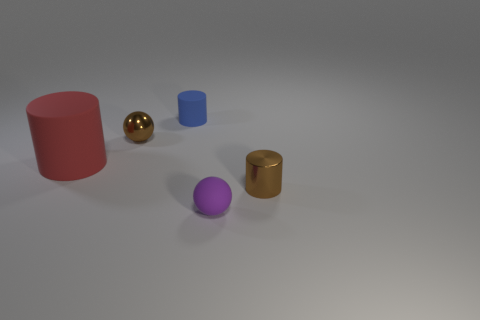Add 4 small matte objects. How many objects exist? 9 Subtract all big red cylinders. How many cylinders are left? 2 Subtract all balls. How many objects are left? 3 Add 5 tiny brown metal cylinders. How many tiny brown metal cylinders are left? 6 Add 1 gray matte objects. How many gray matte objects exist? 1 Subtract 0 green cylinders. How many objects are left? 5 Subtract all purple balls. Subtract all blue cylinders. How many balls are left? 1 Subtract all tiny brown metallic cylinders. Subtract all tiny purple matte things. How many objects are left? 3 